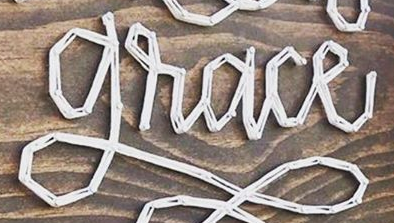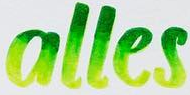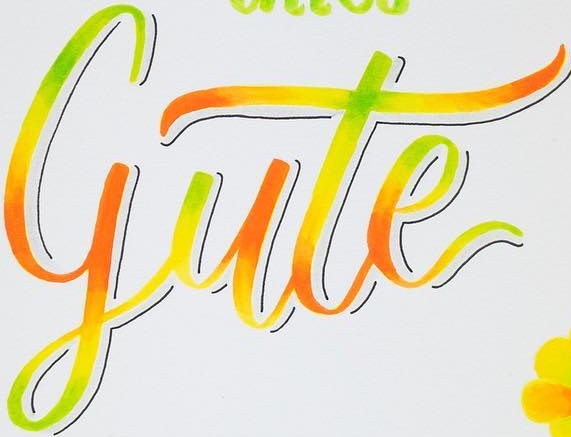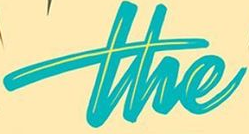Identify the words shown in these images in order, separated by a semicolon. grace; alles; gute; the 